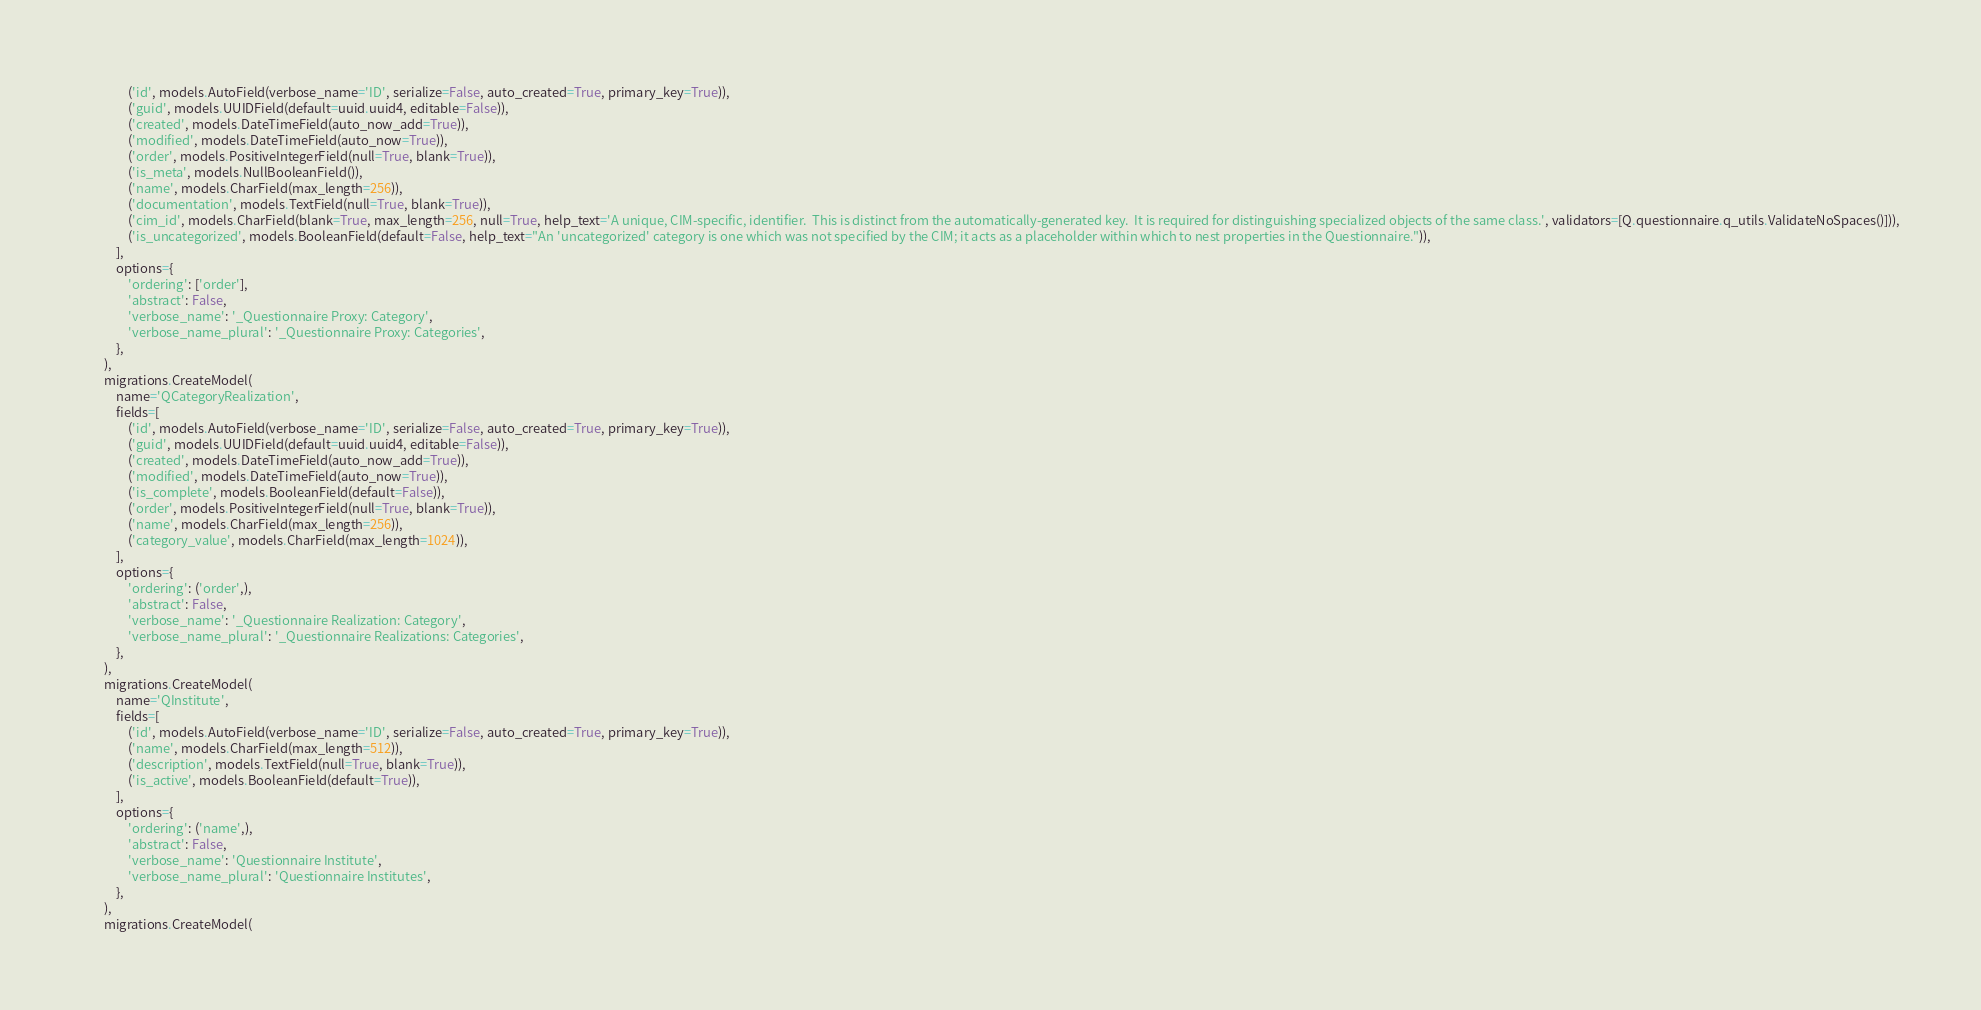<code> <loc_0><loc_0><loc_500><loc_500><_Python_>                ('id', models.AutoField(verbose_name='ID', serialize=False, auto_created=True, primary_key=True)),
                ('guid', models.UUIDField(default=uuid.uuid4, editable=False)),
                ('created', models.DateTimeField(auto_now_add=True)),
                ('modified', models.DateTimeField(auto_now=True)),
                ('order', models.PositiveIntegerField(null=True, blank=True)),
                ('is_meta', models.NullBooleanField()),
                ('name', models.CharField(max_length=256)),
                ('documentation', models.TextField(null=True, blank=True)),
                ('cim_id', models.CharField(blank=True, max_length=256, null=True, help_text='A unique, CIM-specific, identifier.  This is distinct from the automatically-generated key.  It is required for distinguishing specialized objects of the same class.', validators=[Q.questionnaire.q_utils.ValidateNoSpaces()])),
                ('is_uncategorized', models.BooleanField(default=False, help_text="An 'uncategorized' category is one which was not specified by the CIM; it acts as a placeholder within which to nest properties in the Questionnaire.")),
            ],
            options={
                'ordering': ['order'],
                'abstract': False,
                'verbose_name': '_Questionnaire Proxy: Category',
                'verbose_name_plural': '_Questionnaire Proxy: Categories',
            },
        ),
        migrations.CreateModel(
            name='QCategoryRealization',
            fields=[
                ('id', models.AutoField(verbose_name='ID', serialize=False, auto_created=True, primary_key=True)),
                ('guid', models.UUIDField(default=uuid.uuid4, editable=False)),
                ('created', models.DateTimeField(auto_now_add=True)),
                ('modified', models.DateTimeField(auto_now=True)),
                ('is_complete', models.BooleanField(default=False)),
                ('order', models.PositiveIntegerField(null=True, blank=True)),
                ('name', models.CharField(max_length=256)),
                ('category_value', models.CharField(max_length=1024)),
            ],
            options={
                'ordering': ('order',),
                'abstract': False,
                'verbose_name': '_Questionnaire Realization: Category',
                'verbose_name_plural': '_Questionnaire Realizations: Categories',
            },
        ),
        migrations.CreateModel(
            name='QInstitute',
            fields=[
                ('id', models.AutoField(verbose_name='ID', serialize=False, auto_created=True, primary_key=True)),
                ('name', models.CharField(max_length=512)),
                ('description', models.TextField(null=True, blank=True)),
                ('is_active', models.BooleanField(default=True)),
            ],
            options={
                'ordering': ('name',),
                'abstract': False,
                'verbose_name': 'Questionnaire Institute',
                'verbose_name_plural': 'Questionnaire Institutes',
            },
        ),
        migrations.CreateModel(</code> 